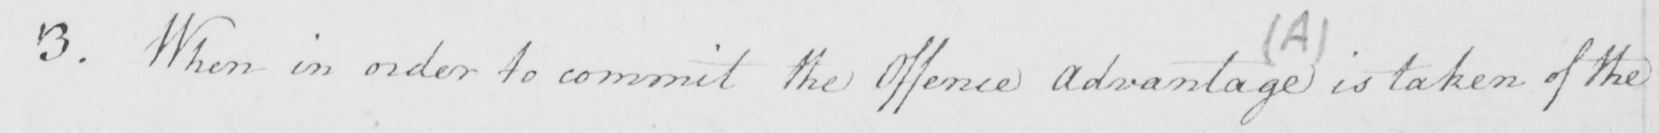Can you read and transcribe this handwriting? 3 . When in order to commit the Offence Advantage is taken of the 